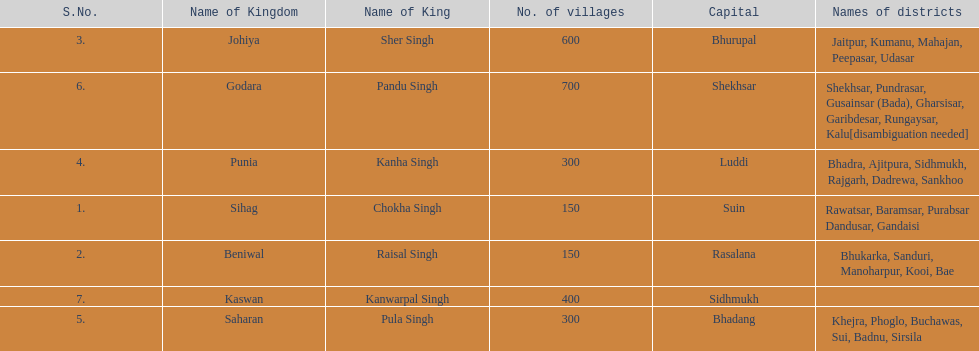What is the next kingdom listed after sihag? Beniwal. 